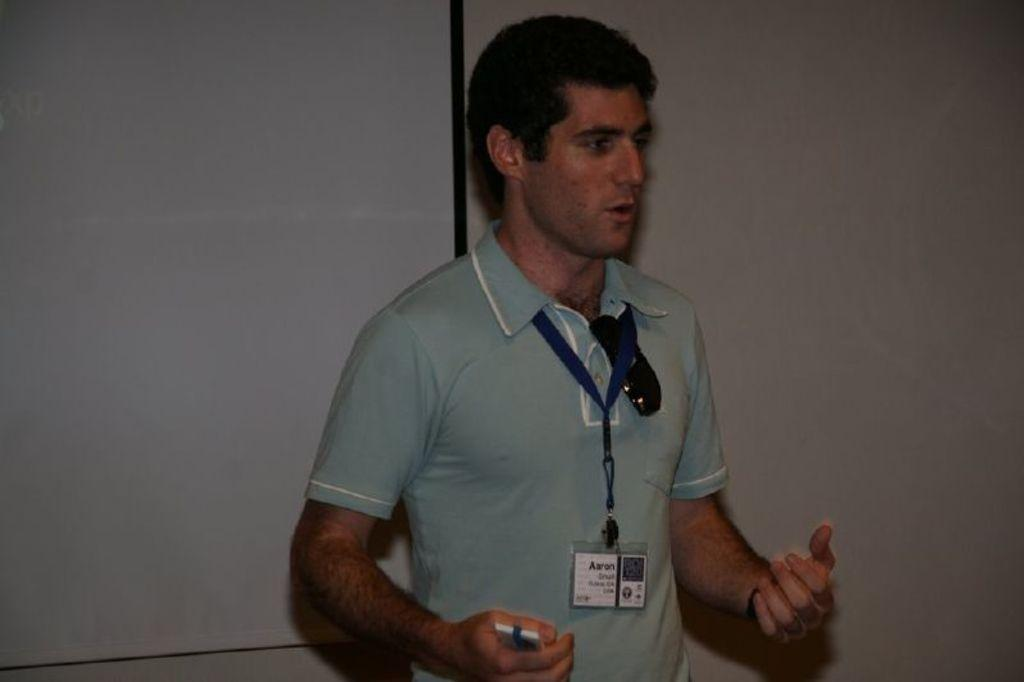What is the main subject in the foreground of the image? There is a man in the foreground of the image. What is the man doing in the image? The man has an opened mouth, which suggests he might be speaking or singing. What is the man wearing in the image? The man is wearing a sky blue T-shirt. Does the man have any identification in the image? Yes, the man has an ID proof. What can be seen in the background of the image? There is a screen and a wall in the background of the image. What type of maid is visible in the image? There is no maid present in the image. What kind of waves can be seen in the image? There are no waves visible in the image. 